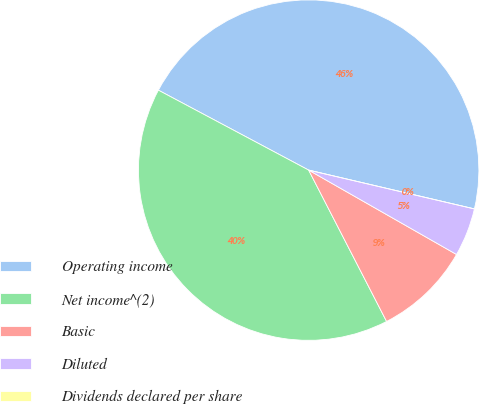Convert chart. <chart><loc_0><loc_0><loc_500><loc_500><pie_chart><fcel>Operating income<fcel>Net income^(2)<fcel>Basic<fcel>Diluted<fcel>Dividends declared per share<nl><fcel>45.88%<fcel>40.35%<fcel>9.18%<fcel>4.59%<fcel>0.0%<nl></chart> 